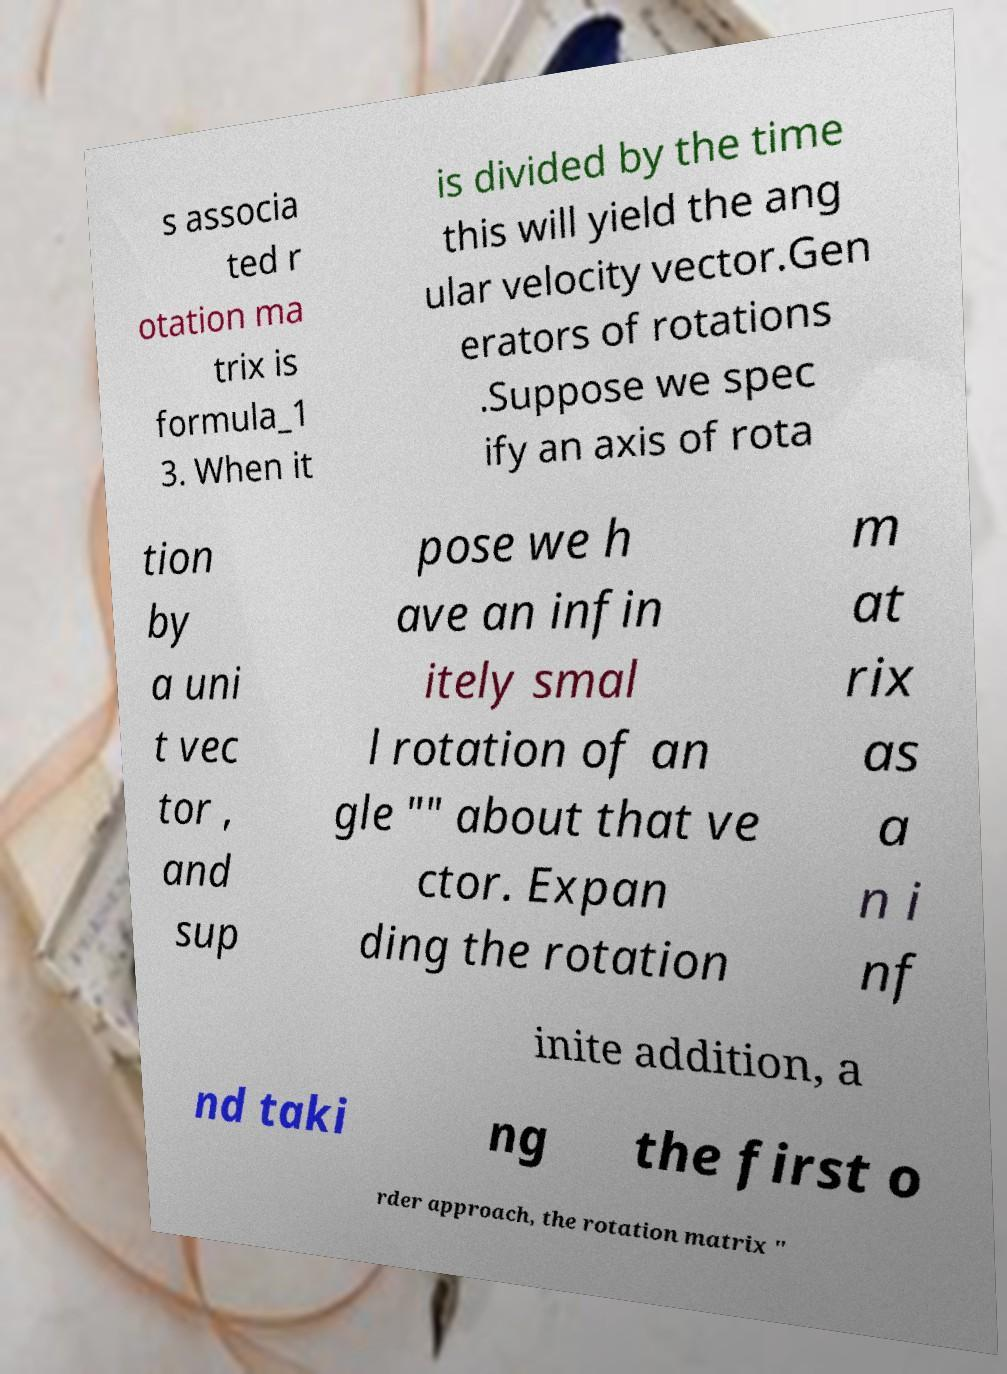I need the written content from this picture converted into text. Can you do that? s associa ted r otation ma trix is formula_1 3. When it is divided by the time this will yield the ang ular velocity vector.Gen erators of rotations .Suppose we spec ify an axis of rota tion by a uni t vec tor , and sup pose we h ave an infin itely smal l rotation of an gle "" about that ve ctor. Expan ding the rotation m at rix as a n i nf inite addition, a nd taki ng the first o rder approach, the rotation matrix " 